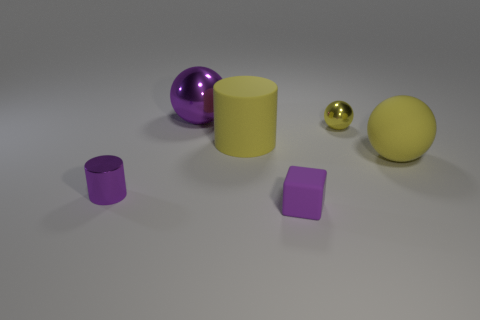Is the material of the purple thing behind the yellow matte cylinder the same as the yellow cylinder?
Provide a short and direct response. No. Are the small thing that is behind the big yellow rubber ball and the cylinder right of the purple metal sphere made of the same material?
Provide a short and direct response. No. Are there more purple rubber objects that are to the right of the small cube than big gray metallic cubes?
Offer a very short reply. No. There is a shiny object in front of the small shiny object right of the tiny cylinder; what is its color?
Your response must be concise. Purple. There is a purple shiny object that is the same size as the yellow matte ball; what shape is it?
Give a very brief answer. Sphere. There is a big matte thing that is the same color as the big matte cylinder; what is its shape?
Give a very brief answer. Sphere. Is the number of small shiny spheres in front of the yellow matte ball the same as the number of big green metallic things?
Offer a very short reply. Yes. What is the material of the big ball in front of the large thing that is behind the yellow rubber thing to the left of the tiny purple cube?
Offer a terse response. Rubber. There is a tiny thing that is made of the same material as the tiny purple cylinder; what is its shape?
Your answer should be compact. Sphere. Is there anything else that has the same color as the matte ball?
Your answer should be very brief. Yes. 